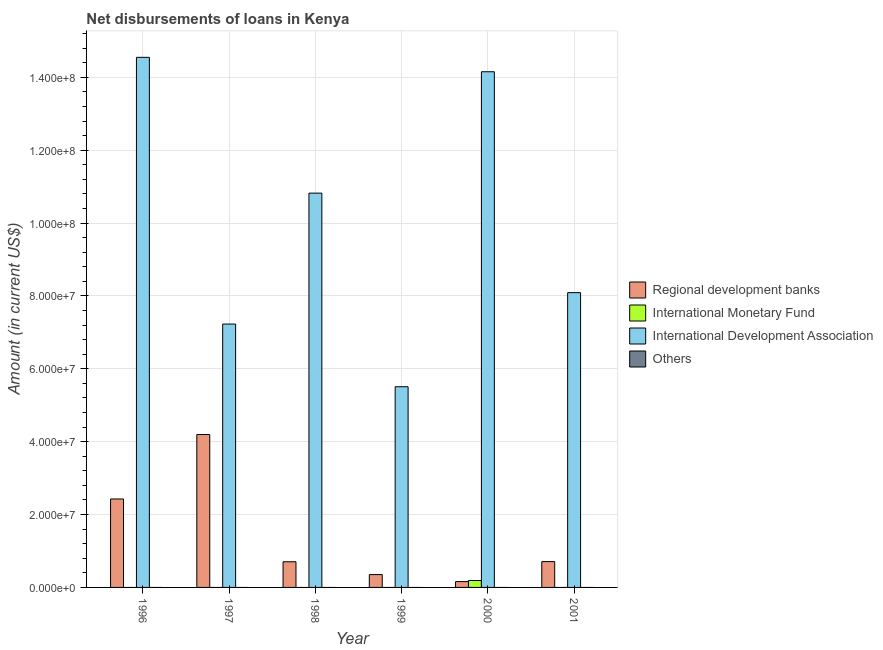Are the number of bars on each tick of the X-axis equal?
Provide a short and direct response. No. How many bars are there on the 2nd tick from the right?
Your response must be concise. 3. Across all years, what is the maximum amount of loan disimbursed by regional development banks?
Offer a very short reply. 4.20e+07. Across all years, what is the minimum amount of loan disimbursed by international monetary fund?
Your response must be concise. 0. In which year was the amount of loan disimbursed by international monetary fund maximum?
Make the answer very short. 2000. What is the total amount of loan disimbursed by international development association in the graph?
Make the answer very short. 6.03e+08. What is the difference between the amount of loan disimbursed by regional development banks in 1997 and that in 2000?
Offer a terse response. 4.04e+07. What is the average amount of loan disimbursed by regional development banks per year?
Give a very brief answer. 1.42e+07. In the year 2000, what is the difference between the amount of loan disimbursed by international development association and amount of loan disimbursed by regional development banks?
Provide a succinct answer. 0. What is the ratio of the amount of loan disimbursed by international development association in 1997 to that in 2000?
Your response must be concise. 0.51. Is the amount of loan disimbursed by regional development banks in 1996 less than that in 1997?
Provide a succinct answer. Yes. What is the difference between the highest and the second highest amount of loan disimbursed by international development association?
Provide a succinct answer. 3.96e+06. What is the difference between the highest and the lowest amount of loan disimbursed by international monetary fund?
Offer a terse response. 1.90e+06. In how many years, is the amount of loan disimbursed by regional development banks greater than the average amount of loan disimbursed by regional development banks taken over all years?
Give a very brief answer. 2. Is it the case that in every year, the sum of the amount of loan disimbursed by international monetary fund and amount of loan disimbursed by other organisations is greater than the sum of amount of loan disimbursed by regional development banks and amount of loan disimbursed by international development association?
Provide a short and direct response. No. What is the difference between two consecutive major ticks on the Y-axis?
Offer a very short reply. 2.00e+07. Does the graph contain grids?
Give a very brief answer. Yes. How many legend labels are there?
Provide a short and direct response. 4. What is the title of the graph?
Ensure brevity in your answer.  Net disbursements of loans in Kenya. What is the label or title of the X-axis?
Your answer should be very brief. Year. What is the label or title of the Y-axis?
Ensure brevity in your answer.  Amount (in current US$). What is the Amount (in current US$) in Regional development banks in 1996?
Your answer should be very brief. 2.43e+07. What is the Amount (in current US$) of International Monetary Fund in 1996?
Offer a terse response. 0. What is the Amount (in current US$) in International Development Association in 1996?
Provide a succinct answer. 1.45e+08. What is the Amount (in current US$) in Others in 1996?
Provide a succinct answer. 0. What is the Amount (in current US$) of Regional development banks in 1997?
Ensure brevity in your answer.  4.20e+07. What is the Amount (in current US$) in International Monetary Fund in 1997?
Give a very brief answer. 0. What is the Amount (in current US$) of International Development Association in 1997?
Your answer should be compact. 7.23e+07. What is the Amount (in current US$) in Regional development banks in 1998?
Give a very brief answer. 7.05e+06. What is the Amount (in current US$) in International Development Association in 1998?
Give a very brief answer. 1.08e+08. What is the Amount (in current US$) in Others in 1998?
Offer a very short reply. 0. What is the Amount (in current US$) in Regional development banks in 1999?
Offer a terse response. 3.52e+06. What is the Amount (in current US$) of International Development Association in 1999?
Make the answer very short. 5.51e+07. What is the Amount (in current US$) of Others in 1999?
Keep it short and to the point. 0. What is the Amount (in current US$) in Regional development banks in 2000?
Your answer should be compact. 1.60e+06. What is the Amount (in current US$) of International Monetary Fund in 2000?
Offer a terse response. 1.90e+06. What is the Amount (in current US$) in International Development Association in 2000?
Give a very brief answer. 1.42e+08. What is the Amount (in current US$) in Regional development banks in 2001?
Keep it short and to the point. 7.09e+06. What is the Amount (in current US$) in International Monetary Fund in 2001?
Make the answer very short. 0. What is the Amount (in current US$) in International Development Association in 2001?
Provide a short and direct response. 8.09e+07. Across all years, what is the maximum Amount (in current US$) in Regional development banks?
Provide a succinct answer. 4.20e+07. Across all years, what is the maximum Amount (in current US$) in International Monetary Fund?
Offer a very short reply. 1.90e+06. Across all years, what is the maximum Amount (in current US$) in International Development Association?
Your answer should be very brief. 1.45e+08. Across all years, what is the minimum Amount (in current US$) of Regional development banks?
Offer a very short reply. 1.60e+06. Across all years, what is the minimum Amount (in current US$) in International Development Association?
Offer a terse response. 5.51e+07. What is the total Amount (in current US$) of Regional development banks in the graph?
Make the answer very short. 8.55e+07. What is the total Amount (in current US$) of International Monetary Fund in the graph?
Offer a terse response. 1.90e+06. What is the total Amount (in current US$) of International Development Association in the graph?
Your response must be concise. 6.03e+08. What is the difference between the Amount (in current US$) in Regional development banks in 1996 and that in 1997?
Your answer should be compact. -1.77e+07. What is the difference between the Amount (in current US$) in International Development Association in 1996 and that in 1997?
Offer a very short reply. 7.32e+07. What is the difference between the Amount (in current US$) in Regional development banks in 1996 and that in 1998?
Provide a succinct answer. 1.72e+07. What is the difference between the Amount (in current US$) of International Development Association in 1996 and that in 1998?
Your answer should be compact. 3.73e+07. What is the difference between the Amount (in current US$) in Regional development banks in 1996 and that in 1999?
Keep it short and to the point. 2.08e+07. What is the difference between the Amount (in current US$) of International Development Association in 1996 and that in 1999?
Offer a terse response. 9.04e+07. What is the difference between the Amount (in current US$) in Regional development banks in 1996 and that in 2000?
Provide a short and direct response. 2.27e+07. What is the difference between the Amount (in current US$) in International Development Association in 1996 and that in 2000?
Offer a terse response. 3.96e+06. What is the difference between the Amount (in current US$) of Regional development banks in 1996 and that in 2001?
Offer a terse response. 1.72e+07. What is the difference between the Amount (in current US$) in International Development Association in 1996 and that in 2001?
Offer a terse response. 6.46e+07. What is the difference between the Amount (in current US$) of Regional development banks in 1997 and that in 1998?
Your answer should be very brief. 3.49e+07. What is the difference between the Amount (in current US$) in International Development Association in 1997 and that in 1998?
Your answer should be compact. -3.59e+07. What is the difference between the Amount (in current US$) in Regional development banks in 1997 and that in 1999?
Your answer should be very brief. 3.84e+07. What is the difference between the Amount (in current US$) of International Development Association in 1997 and that in 1999?
Offer a very short reply. 1.72e+07. What is the difference between the Amount (in current US$) in Regional development banks in 1997 and that in 2000?
Offer a terse response. 4.04e+07. What is the difference between the Amount (in current US$) in International Development Association in 1997 and that in 2000?
Make the answer very short. -6.92e+07. What is the difference between the Amount (in current US$) in Regional development banks in 1997 and that in 2001?
Your response must be concise. 3.49e+07. What is the difference between the Amount (in current US$) of International Development Association in 1997 and that in 2001?
Ensure brevity in your answer.  -8.62e+06. What is the difference between the Amount (in current US$) in Regional development banks in 1998 and that in 1999?
Your answer should be very brief. 3.52e+06. What is the difference between the Amount (in current US$) of International Development Association in 1998 and that in 1999?
Keep it short and to the point. 5.31e+07. What is the difference between the Amount (in current US$) of Regional development banks in 1998 and that in 2000?
Your answer should be very brief. 5.44e+06. What is the difference between the Amount (in current US$) of International Development Association in 1998 and that in 2000?
Your response must be concise. -3.33e+07. What is the difference between the Amount (in current US$) in Regional development banks in 1998 and that in 2001?
Offer a very short reply. -4.30e+04. What is the difference between the Amount (in current US$) of International Development Association in 1998 and that in 2001?
Your response must be concise. 2.73e+07. What is the difference between the Amount (in current US$) in Regional development banks in 1999 and that in 2000?
Offer a very short reply. 1.92e+06. What is the difference between the Amount (in current US$) of International Development Association in 1999 and that in 2000?
Provide a succinct answer. -8.64e+07. What is the difference between the Amount (in current US$) of Regional development banks in 1999 and that in 2001?
Ensure brevity in your answer.  -3.57e+06. What is the difference between the Amount (in current US$) in International Development Association in 1999 and that in 2001?
Offer a terse response. -2.58e+07. What is the difference between the Amount (in current US$) of Regional development banks in 2000 and that in 2001?
Give a very brief answer. -5.49e+06. What is the difference between the Amount (in current US$) in International Development Association in 2000 and that in 2001?
Provide a short and direct response. 6.06e+07. What is the difference between the Amount (in current US$) in Regional development banks in 1996 and the Amount (in current US$) in International Development Association in 1997?
Make the answer very short. -4.80e+07. What is the difference between the Amount (in current US$) of Regional development banks in 1996 and the Amount (in current US$) of International Development Association in 1998?
Your answer should be compact. -8.39e+07. What is the difference between the Amount (in current US$) of Regional development banks in 1996 and the Amount (in current US$) of International Development Association in 1999?
Make the answer very short. -3.08e+07. What is the difference between the Amount (in current US$) of Regional development banks in 1996 and the Amount (in current US$) of International Monetary Fund in 2000?
Provide a short and direct response. 2.24e+07. What is the difference between the Amount (in current US$) in Regional development banks in 1996 and the Amount (in current US$) in International Development Association in 2000?
Give a very brief answer. -1.17e+08. What is the difference between the Amount (in current US$) in Regional development banks in 1996 and the Amount (in current US$) in International Development Association in 2001?
Offer a terse response. -5.66e+07. What is the difference between the Amount (in current US$) in Regional development banks in 1997 and the Amount (in current US$) in International Development Association in 1998?
Provide a short and direct response. -6.63e+07. What is the difference between the Amount (in current US$) in Regional development banks in 1997 and the Amount (in current US$) in International Development Association in 1999?
Give a very brief answer. -1.31e+07. What is the difference between the Amount (in current US$) of Regional development banks in 1997 and the Amount (in current US$) of International Monetary Fund in 2000?
Provide a succinct answer. 4.01e+07. What is the difference between the Amount (in current US$) in Regional development banks in 1997 and the Amount (in current US$) in International Development Association in 2000?
Provide a short and direct response. -9.96e+07. What is the difference between the Amount (in current US$) in Regional development banks in 1997 and the Amount (in current US$) in International Development Association in 2001?
Your answer should be compact. -3.89e+07. What is the difference between the Amount (in current US$) in Regional development banks in 1998 and the Amount (in current US$) in International Development Association in 1999?
Offer a very short reply. -4.80e+07. What is the difference between the Amount (in current US$) of Regional development banks in 1998 and the Amount (in current US$) of International Monetary Fund in 2000?
Provide a succinct answer. 5.15e+06. What is the difference between the Amount (in current US$) of Regional development banks in 1998 and the Amount (in current US$) of International Development Association in 2000?
Your answer should be compact. -1.34e+08. What is the difference between the Amount (in current US$) of Regional development banks in 1998 and the Amount (in current US$) of International Development Association in 2001?
Your answer should be very brief. -7.39e+07. What is the difference between the Amount (in current US$) of Regional development banks in 1999 and the Amount (in current US$) of International Monetary Fund in 2000?
Provide a short and direct response. 1.63e+06. What is the difference between the Amount (in current US$) of Regional development banks in 1999 and the Amount (in current US$) of International Development Association in 2000?
Offer a terse response. -1.38e+08. What is the difference between the Amount (in current US$) in Regional development banks in 1999 and the Amount (in current US$) in International Development Association in 2001?
Your answer should be compact. -7.74e+07. What is the difference between the Amount (in current US$) in Regional development banks in 2000 and the Amount (in current US$) in International Development Association in 2001?
Offer a terse response. -7.93e+07. What is the difference between the Amount (in current US$) in International Monetary Fund in 2000 and the Amount (in current US$) in International Development Association in 2001?
Give a very brief answer. -7.90e+07. What is the average Amount (in current US$) of Regional development banks per year?
Provide a succinct answer. 1.42e+07. What is the average Amount (in current US$) in International Monetary Fund per year?
Give a very brief answer. 3.16e+05. What is the average Amount (in current US$) in International Development Association per year?
Ensure brevity in your answer.  1.01e+08. In the year 1996, what is the difference between the Amount (in current US$) in Regional development banks and Amount (in current US$) in International Development Association?
Your answer should be very brief. -1.21e+08. In the year 1997, what is the difference between the Amount (in current US$) of Regional development banks and Amount (in current US$) of International Development Association?
Keep it short and to the point. -3.03e+07. In the year 1998, what is the difference between the Amount (in current US$) of Regional development banks and Amount (in current US$) of International Development Association?
Give a very brief answer. -1.01e+08. In the year 1999, what is the difference between the Amount (in current US$) in Regional development banks and Amount (in current US$) in International Development Association?
Give a very brief answer. -5.16e+07. In the year 2000, what is the difference between the Amount (in current US$) of Regional development banks and Amount (in current US$) of International Monetary Fund?
Ensure brevity in your answer.  -2.95e+05. In the year 2000, what is the difference between the Amount (in current US$) in Regional development banks and Amount (in current US$) in International Development Association?
Your response must be concise. -1.40e+08. In the year 2000, what is the difference between the Amount (in current US$) in International Monetary Fund and Amount (in current US$) in International Development Association?
Ensure brevity in your answer.  -1.40e+08. In the year 2001, what is the difference between the Amount (in current US$) in Regional development banks and Amount (in current US$) in International Development Association?
Provide a succinct answer. -7.38e+07. What is the ratio of the Amount (in current US$) in Regional development banks in 1996 to that in 1997?
Your answer should be very brief. 0.58. What is the ratio of the Amount (in current US$) in International Development Association in 1996 to that in 1997?
Provide a succinct answer. 2.01. What is the ratio of the Amount (in current US$) in Regional development banks in 1996 to that in 1998?
Your response must be concise. 3.45. What is the ratio of the Amount (in current US$) in International Development Association in 1996 to that in 1998?
Offer a very short reply. 1.34. What is the ratio of the Amount (in current US$) in Regional development banks in 1996 to that in 1999?
Provide a short and direct response. 6.89. What is the ratio of the Amount (in current US$) in International Development Association in 1996 to that in 1999?
Keep it short and to the point. 2.64. What is the ratio of the Amount (in current US$) of Regional development banks in 1996 to that in 2000?
Keep it short and to the point. 15.16. What is the ratio of the Amount (in current US$) of International Development Association in 1996 to that in 2000?
Give a very brief answer. 1.03. What is the ratio of the Amount (in current US$) of Regional development banks in 1996 to that in 2001?
Offer a very short reply. 3.42. What is the ratio of the Amount (in current US$) of International Development Association in 1996 to that in 2001?
Offer a terse response. 1.8. What is the ratio of the Amount (in current US$) of Regional development banks in 1997 to that in 1998?
Your answer should be compact. 5.95. What is the ratio of the Amount (in current US$) in International Development Association in 1997 to that in 1998?
Offer a very short reply. 0.67. What is the ratio of the Amount (in current US$) in Regional development banks in 1997 to that in 1999?
Your response must be concise. 11.91. What is the ratio of the Amount (in current US$) in International Development Association in 1997 to that in 1999?
Provide a succinct answer. 1.31. What is the ratio of the Amount (in current US$) of Regional development banks in 1997 to that in 2000?
Your response must be concise. 26.21. What is the ratio of the Amount (in current US$) in International Development Association in 1997 to that in 2000?
Offer a terse response. 0.51. What is the ratio of the Amount (in current US$) in Regional development banks in 1997 to that in 2001?
Provide a short and direct response. 5.92. What is the ratio of the Amount (in current US$) in International Development Association in 1997 to that in 2001?
Keep it short and to the point. 0.89. What is the ratio of the Amount (in current US$) of Regional development banks in 1998 to that in 1999?
Your response must be concise. 2. What is the ratio of the Amount (in current US$) in International Development Association in 1998 to that in 1999?
Your answer should be compact. 1.96. What is the ratio of the Amount (in current US$) in Regional development banks in 1998 to that in 2000?
Keep it short and to the point. 4.4. What is the ratio of the Amount (in current US$) of International Development Association in 1998 to that in 2000?
Offer a terse response. 0.76. What is the ratio of the Amount (in current US$) of Regional development banks in 1998 to that in 2001?
Offer a terse response. 0.99. What is the ratio of the Amount (in current US$) in International Development Association in 1998 to that in 2001?
Offer a terse response. 1.34. What is the ratio of the Amount (in current US$) in Regional development banks in 1999 to that in 2000?
Your response must be concise. 2.2. What is the ratio of the Amount (in current US$) in International Development Association in 1999 to that in 2000?
Offer a terse response. 0.39. What is the ratio of the Amount (in current US$) in Regional development banks in 1999 to that in 2001?
Provide a succinct answer. 0.5. What is the ratio of the Amount (in current US$) of International Development Association in 1999 to that in 2001?
Keep it short and to the point. 0.68. What is the ratio of the Amount (in current US$) of Regional development banks in 2000 to that in 2001?
Give a very brief answer. 0.23. What is the ratio of the Amount (in current US$) of International Development Association in 2000 to that in 2001?
Make the answer very short. 1.75. What is the difference between the highest and the second highest Amount (in current US$) of Regional development banks?
Make the answer very short. 1.77e+07. What is the difference between the highest and the second highest Amount (in current US$) in International Development Association?
Provide a succinct answer. 3.96e+06. What is the difference between the highest and the lowest Amount (in current US$) of Regional development banks?
Make the answer very short. 4.04e+07. What is the difference between the highest and the lowest Amount (in current US$) in International Monetary Fund?
Provide a succinct answer. 1.90e+06. What is the difference between the highest and the lowest Amount (in current US$) in International Development Association?
Keep it short and to the point. 9.04e+07. 